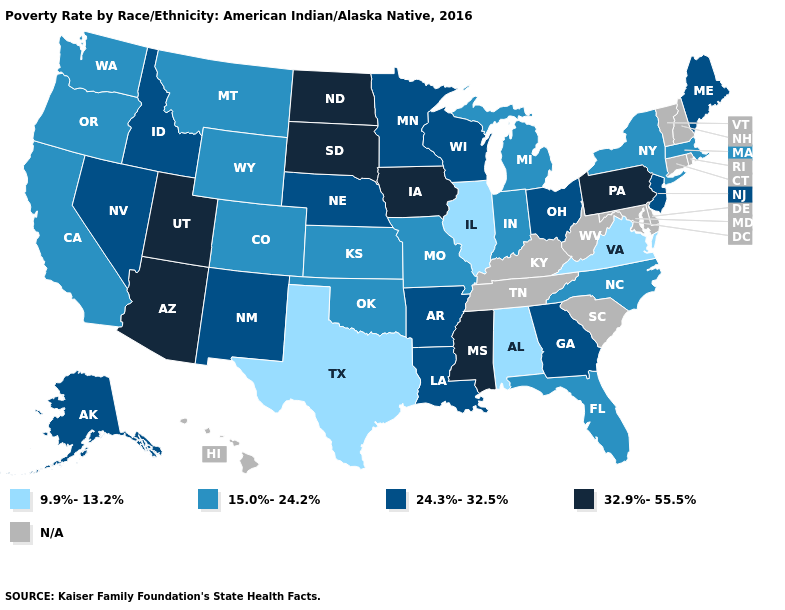What is the lowest value in the USA?
Answer briefly. 9.9%-13.2%. Which states hav the highest value in the South?
Keep it brief. Mississippi. Name the states that have a value in the range 24.3%-32.5%?
Quick response, please. Alaska, Arkansas, Georgia, Idaho, Louisiana, Maine, Minnesota, Nebraska, Nevada, New Jersey, New Mexico, Ohio, Wisconsin. Which states have the lowest value in the USA?
Be succinct. Alabama, Illinois, Texas, Virginia. Name the states that have a value in the range 32.9%-55.5%?
Write a very short answer. Arizona, Iowa, Mississippi, North Dakota, Pennsylvania, South Dakota, Utah. What is the value of Hawaii?
Short answer required. N/A. Which states have the lowest value in the USA?
Answer briefly. Alabama, Illinois, Texas, Virginia. What is the value of Oregon?
Be succinct. 15.0%-24.2%. Among the states that border Indiana , which have the highest value?
Answer briefly. Ohio. Name the states that have a value in the range 32.9%-55.5%?
Concise answer only. Arizona, Iowa, Mississippi, North Dakota, Pennsylvania, South Dakota, Utah. What is the value of Texas?
Short answer required. 9.9%-13.2%. Does Pennsylvania have the lowest value in the Northeast?
Be succinct. No. Among the states that border New Jersey , does Pennsylvania have the highest value?
Short answer required. Yes. Does Oregon have the lowest value in the West?
Short answer required. Yes. Among the states that border New Jersey , does New York have the lowest value?
Concise answer only. Yes. 